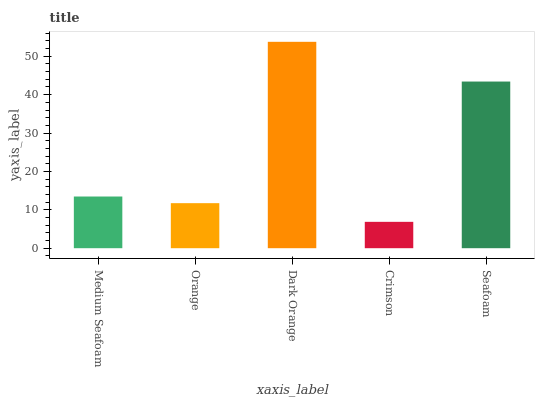Is Crimson the minimum?
Answer yes or no. Yes. Is Dark Orange the maximum?
Answer yes or no. Yes. Is Orange the minimum?
Answer yes or no. No. Is Orange the maximum?
Answer yes or no. No. Is Medium Seafoam greater than Orange?
Answer yes or no. Yes. Is Orange less than Medium Seafoam?
Answer yes or no. Yes. Is Orange greater than Medium Seafoam?
Answer yes or no. No. Is Medium Seafoam less than Orange?
Answer yes or no. No. Is Medium Seafoam the high median?
Answer yes or no. Yes. Is Medium Seafoam the low median?
Answer yes or no. Yes. Is Crimson the high median?
Answer yes or no. No. Is Crimson the low median?
Answer yes or no. No. 